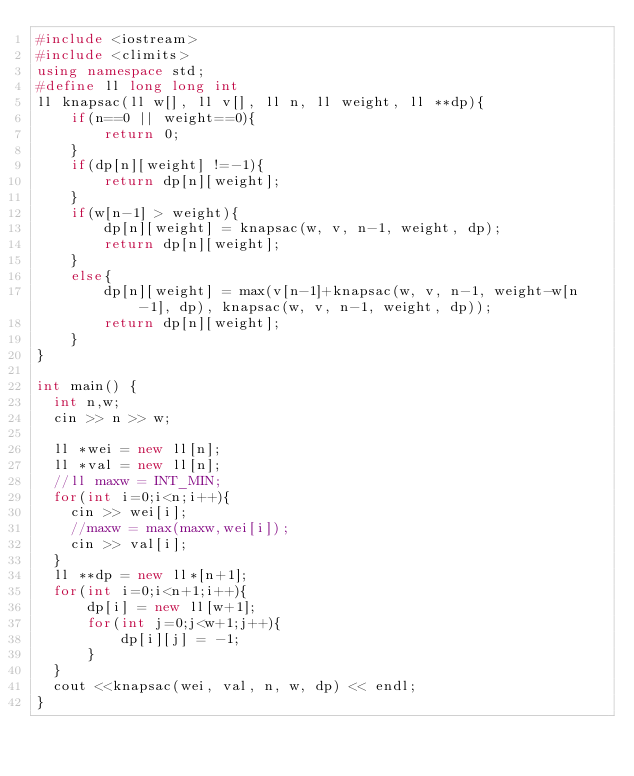Convert code to text. <code><loc_0><loc_0><loc_500><loc_500><_C++_>#include <iostream>
#include <climits>
using namespace std;
#define ll long long int
ll knapsac(ll w[], ll v[], ll n, ll weight, ll **dp){
    if(n==0 || weight==0){
        return 0;
    }
    if(dp[n][weight] !=-1){
        return dp[n][weight];
    }
    if(w[n-1] > weight){
        dp[n][weight] = knapsac(w, v, n-1, weight, dp);
        return dp[n][weight];
    }
    else{
        dp[n][weight] = max(v[n-1]+knapsac(w, v, n-1, weight-w[n-1], dp), knapsac(w, v, n-1, weight, dp));
        return dp[n][weight];
    }
}

int main() {
  int n,w;
  cin >> n >> w;
  
  ll *wei = new ll[n];
  ll *val = new ll[n];
  //ll maxw = INT_MIN;
  for(int i=0;i<n;i++){
  	cin >> wei[i];
    //maxw = max(maxw,wei[i]);
    cin >> val[i];
  }
  ll **dp = new ll*[n+1];
  for(int i=0;i<n+1;i++){
      dp[i] = new ll[w+1];
      for(int j=0;j<w+1;j++){
          dp[i][j] = -1;
      }
  }
  cout <<knapsac(wei, val, n, w, dp) << endl;
}
</code> 